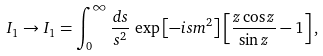Convert formula to latex. <formula><loc_0><loc_0><loc_500><loc_500>I _ { 1 } \rightarrow I _ { 1 } = \int _ { 0 } ^ { \infty } \frac { d s } { s ^ { 2 } } \, \exp \left [ - i s m ^ { 2 } \right ] \left [ \frac { z \cos z } { \sin z } - 1 \right ] ,</formula> 